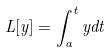Convert formula to latex. <formula><loc_0><loc_0><loc_500><loc_500>L [ y ] = \int _ { a } ^ { t } y d t</formula> 